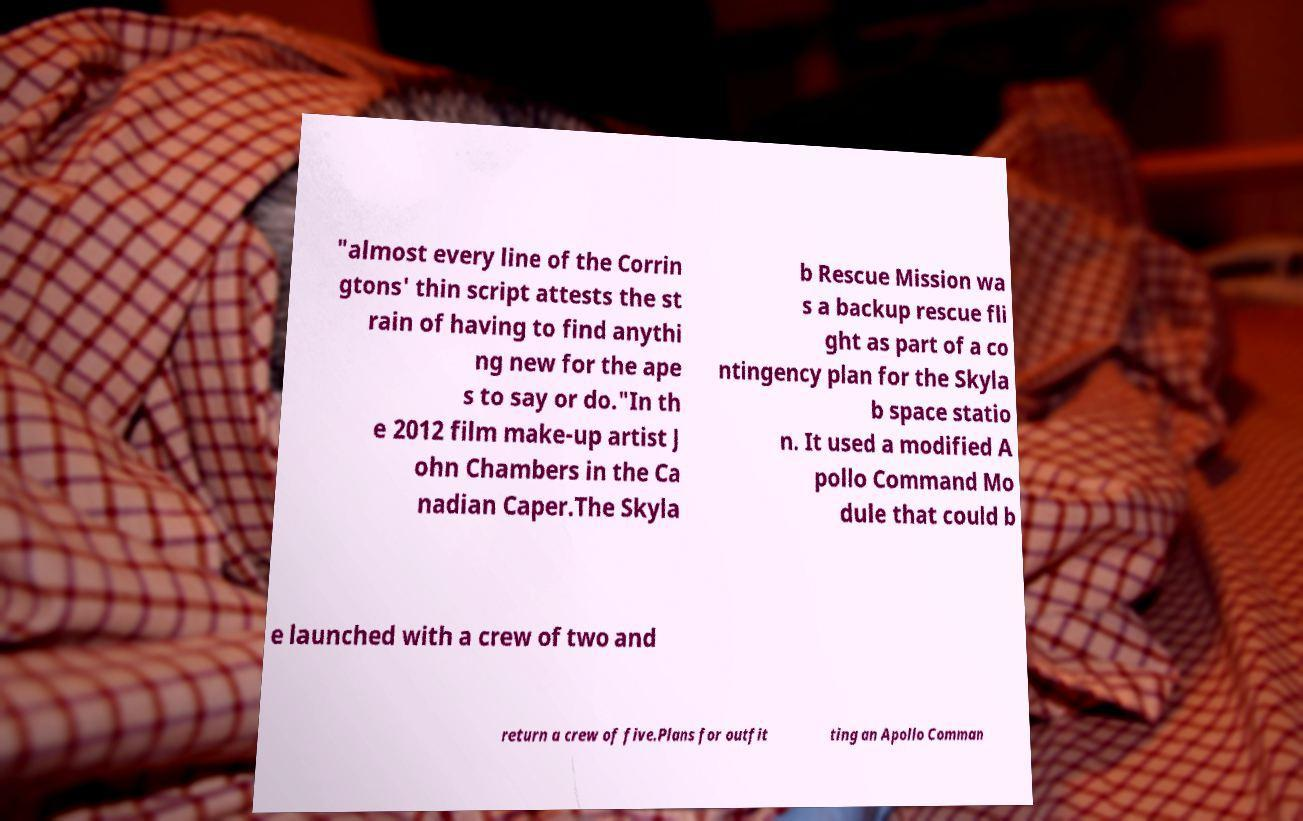For documentation purposes, I need the text within this image transcribed. Could you provide that? "almost every line of the Corrin gtons' thin script attests the st rain of having to find anythi ng new for the ape s to say or do."In th e 2012 film make-up artist J ohn Chambers in the Ca nadian Caper.The Skyla b Rescue Mission wa s a backup rescue fli ght as part of a co ntingency plan for the Skyla b space statio n. It used a modified A pollo Command Mo dule that could b e launched with a crew of two and return a crew of five.Plans for outfit ting an Apollo Comman 